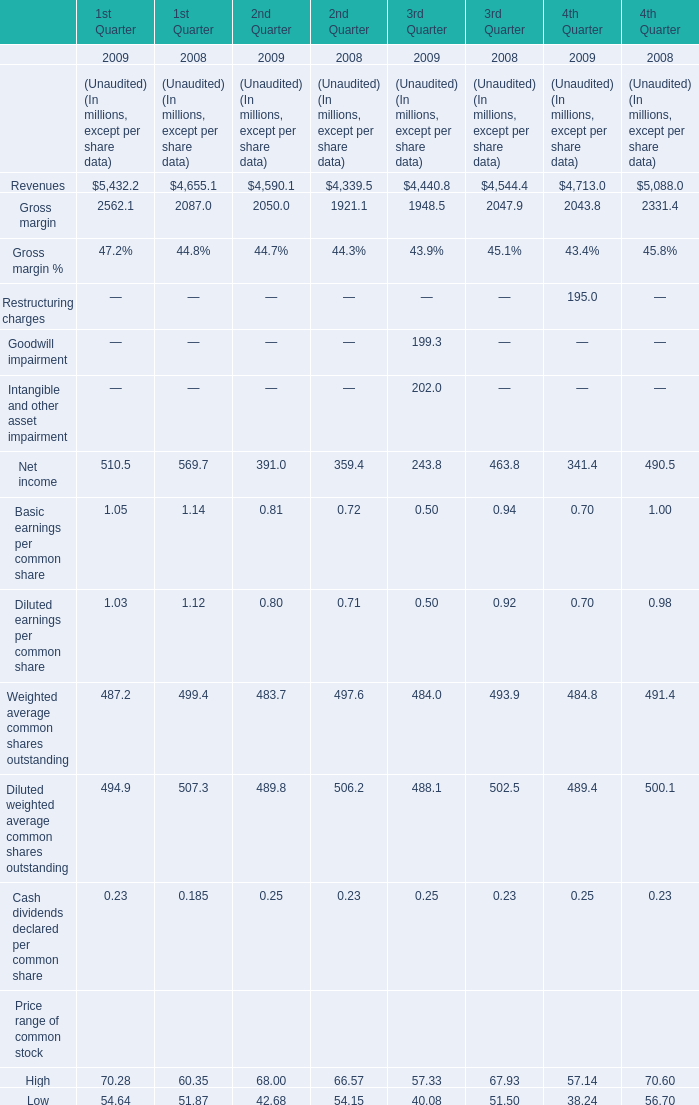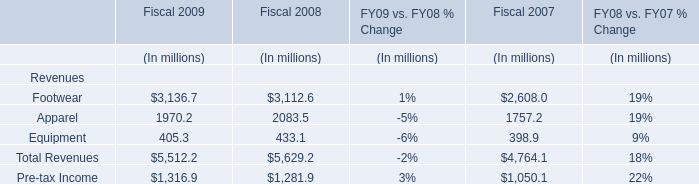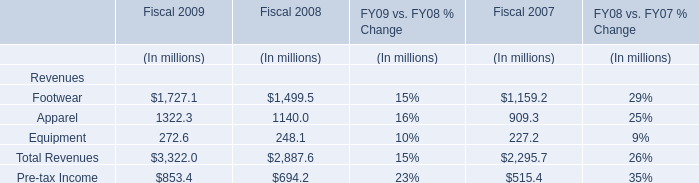Which year is Net income for 2nd Quarter the most? 
Answer: 2009. 